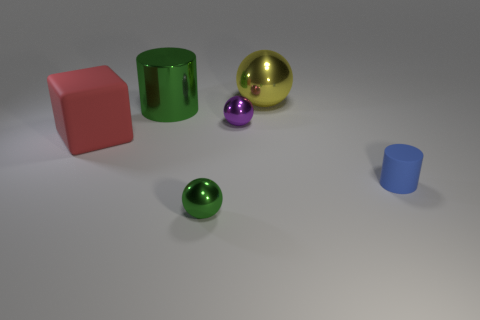What number of red metal cylinders are there?
Give a very brief answer. 0. There is a thing behind the green shiny thing behind the blue thing; is there a blue object in front of it?
Provide a short and direct response. Yes. There is a green thing that is the same size as the yellow shiny ball; what is its shape?
Provide a succinct answer. Cylinder. How many other things are the same color as the shiny cylinder?
Provide a short and direct response. 1. What material is the purple object?
Provide a short and direct response. Metal. What number of other objects are the same material as the big block?
Provide a succinct answer. 1. There is a metal object that is both left of the tiny purple metal object and on the right side of the large cylinder; how big is it?
Offer a very short reply. Small. There is a small shiny thing behind the small sphere in front of the large rubber block; what shape is it?
Your answer should be very brief. Sphere. Is there anything else that has the same shape as the big yellow metallic thing?
Make the answer very short. Yes. Are there the same number of balls behind the big shiny cylinder and gray matte cubes?
Offer a terse response. No. 